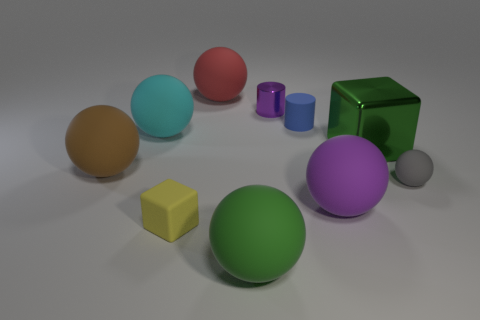What number of other objects are there of the same size as the cyan object?
Offer a terse response. 5. Are there any yellow objects to the right of the large green thing left of the green thing that is behind the large brown matte thing?
Your response must be concise. No. Does the ball that is behind the cyan rubber object have the same material as the big green cube?
Make the answer very short. No. What is the color of the other matte object that is the same shape as the small purple thing?
Give a very brief answer. Blue. Is there anything else that has the same shape as the yellow thing?
Your answer should be very brief. Yes. Are there the same number of gray matte balls on the left side of the brown matte object and big brown objects?
Make the answer very short. No. Are there any gray spheres right of the gray thing?
Keep it short and to the point. No. What size is the thing on the right side of the green cube right of the purple object that is behind the big brown matte ball?
Your answer should be compact. Small. There is a large green object that is to the right of the tiny blue matte cylinder; is its shape the same as the big object in front of the yellow rubber block?
Your answer should be very brief. No. There is another object that is the same shape as the large shiny object; what size is it?
Your response must be concise. Small. 